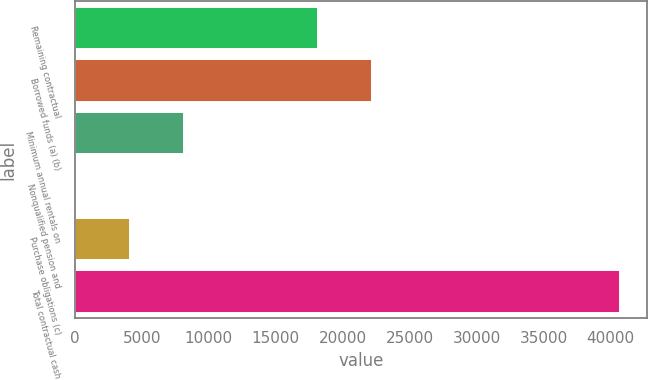<chart> <loc_0><loc_0><loc_500><loc_500><bar_chart><fcel>Remaining contractual<fcel>Borrowed funds (a) (b)<fcel>Minimum annual rentals on<fcel>Nonqualified pension and<fcel>Purchase obligations (c)<fcel>Total contractual cash<nl><fcel>18155<fcel>22214.4<fcel>8184.8<fcel>66<fcel>4125.4<fcel>40660<nl></chart> 